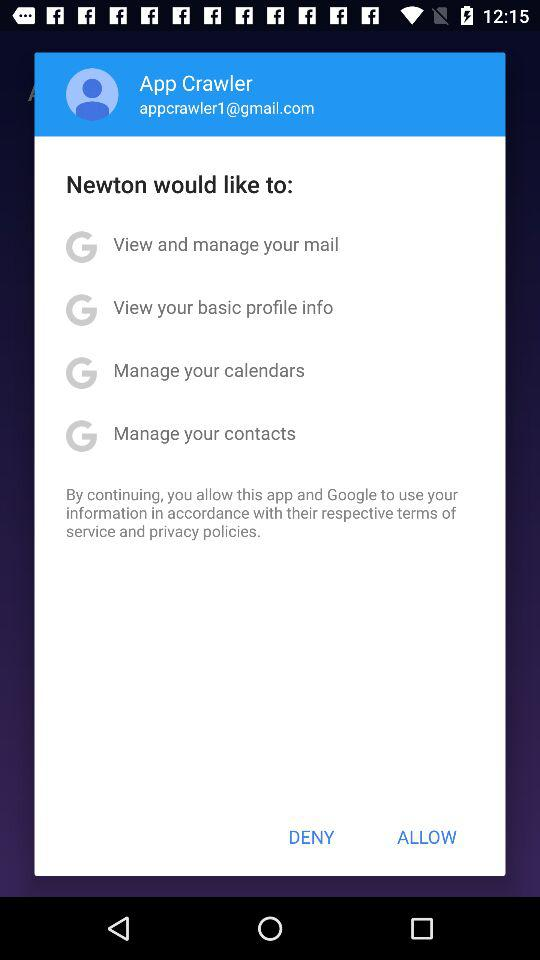What is the user name? The username is App Crawler. 